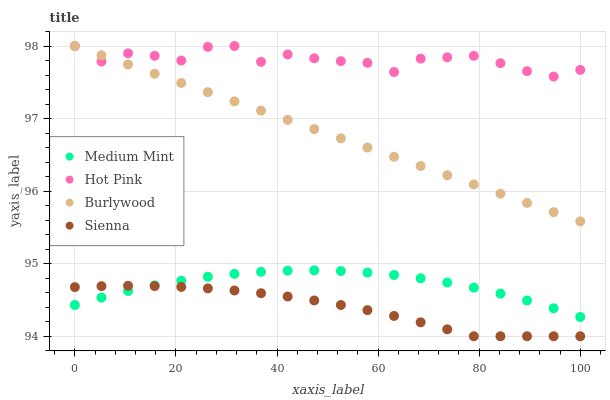Does Sienna have the minimum area under the curve?
Answer yes or no. Yes. Does Hot Pink have the maximum area under the curve?
Answer yes or no. Yes. Does Burlywood have the minimum area under the curve?
Answer yes or no. No. Does Burlywood have the maximum area under the curve?
Answer yes or no. No. Is Burlywood the smoothest?
Answer yes or no. Yes. Is Hot Pink the roughest?
Answer yes or no. Yes. Is Hot Pink the smoothest?
Answer yes or no. No. Is Burlywood the roughest?
Answer yes or no. No. Does Sienna have the lowest value?
Answer yes or no. Yes. Does Burlywood have the lowest value?
Answer yes or no. No. Does Hot Pink have the highest value?
Answer yes or no. Yes. Does Sienna have the highest value?
Answer yes or no. No. Is Medium Mint less than Hot Pink?
Answer yes or no. Yes. Is Hot Pink greater than Sienna?
Answer yes or no. Yes. Does Sienna intersect Medium Mint?
Answer yes or no. Yes. Is Sienna less than Medium Mint?
Answer yes or no. No. Is Sienna greater than Medium Mint?
Answer yes or no. No. Does Medium Mint intersect Hot Pink?
Answer yes or no. No. 